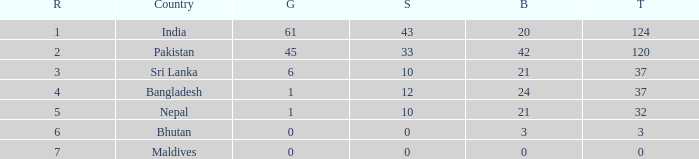How much Rank has a Bronze of 21, and a Silver larger than 10? 0.0. 